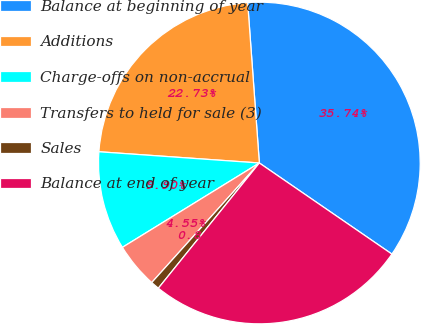<chart> <loc_0><loc_0><loc_500><loc_500><pie_chart><fcel>Balance at beginning of year<fcel>Additions<fcel>Charge-offs on non-accrual<fcel>Transfers to held for sale (3)<fcel>Sales<fcel>Balance at end of year<nl><fcel>35.74%<fcel>22.73%<fcel>9.9%<fcel>4.55%<fcel>0.86%<fcel>26.22%<nl></chart> 